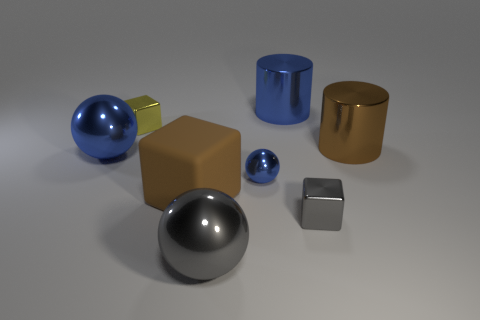What is the color of the thing that is to the left of the tiny yellow metallic object?
Your answer should be compact. Blue. There is a big gray metallic object; how many brown objects are behind it?
Keep it short and to the point. 2. What number of other things are the same size as the brown rubber thing?
Keep it short and to the point. 4. What is the size of the brown rubber object that is the same shape as the yellow thing?
Give a very brief answer. Large. What is the shape of the small metal thing on the left side of the brown matte block?
Offer a terse response. Cube. What is the color of the big metal thing that is in front of the sphere left of the gray metal ball?
Offer a terse response. Gray. What number of objects are large things that are left of the gray metal cube or small spheres?
Offer a very short reply. 5. There is a gray shiny sphere; is it the same size as the ball left of the big block?
Your answer should be very brief. Yes. How many large objects are either blue metallic things or blue cylinders?
Your response must be concise. 2. What is the shape of the big brown matte object?
Keep it short and to the point. Cube. 